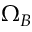Convert formula to latex. <formula><loc_0><loc_0><loc_500><loc_500>\Omega _ { B }</formula> 